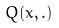<formula> <loc_0><loc_0><loc_500><loc_500>Q ( x , . )</formula> 